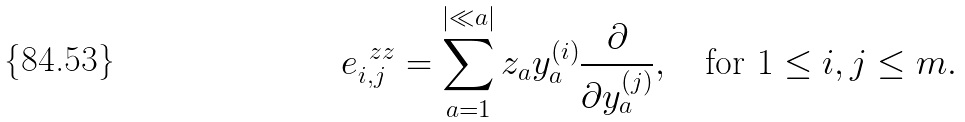Convert formula to latex. <formula><loc_0><loc_0><loc_500><loc_500>e ^ { \ z z } _ { i , j } = \sum _ { a = 1 } ^ { | \ll a | } z _ { a } y _ { a } ^ { ( i ) } \frac { \partial } { \partial y ^ { ( j ) } _ { a } } , \quad \text {for} \ 1 \leq i , j \leq m .</formula> 